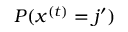<formula> <loc_0><loc_0><loc_500><loc_500>P ( x ^ { ( t ) } = j ^ { \prime } )</formula> 